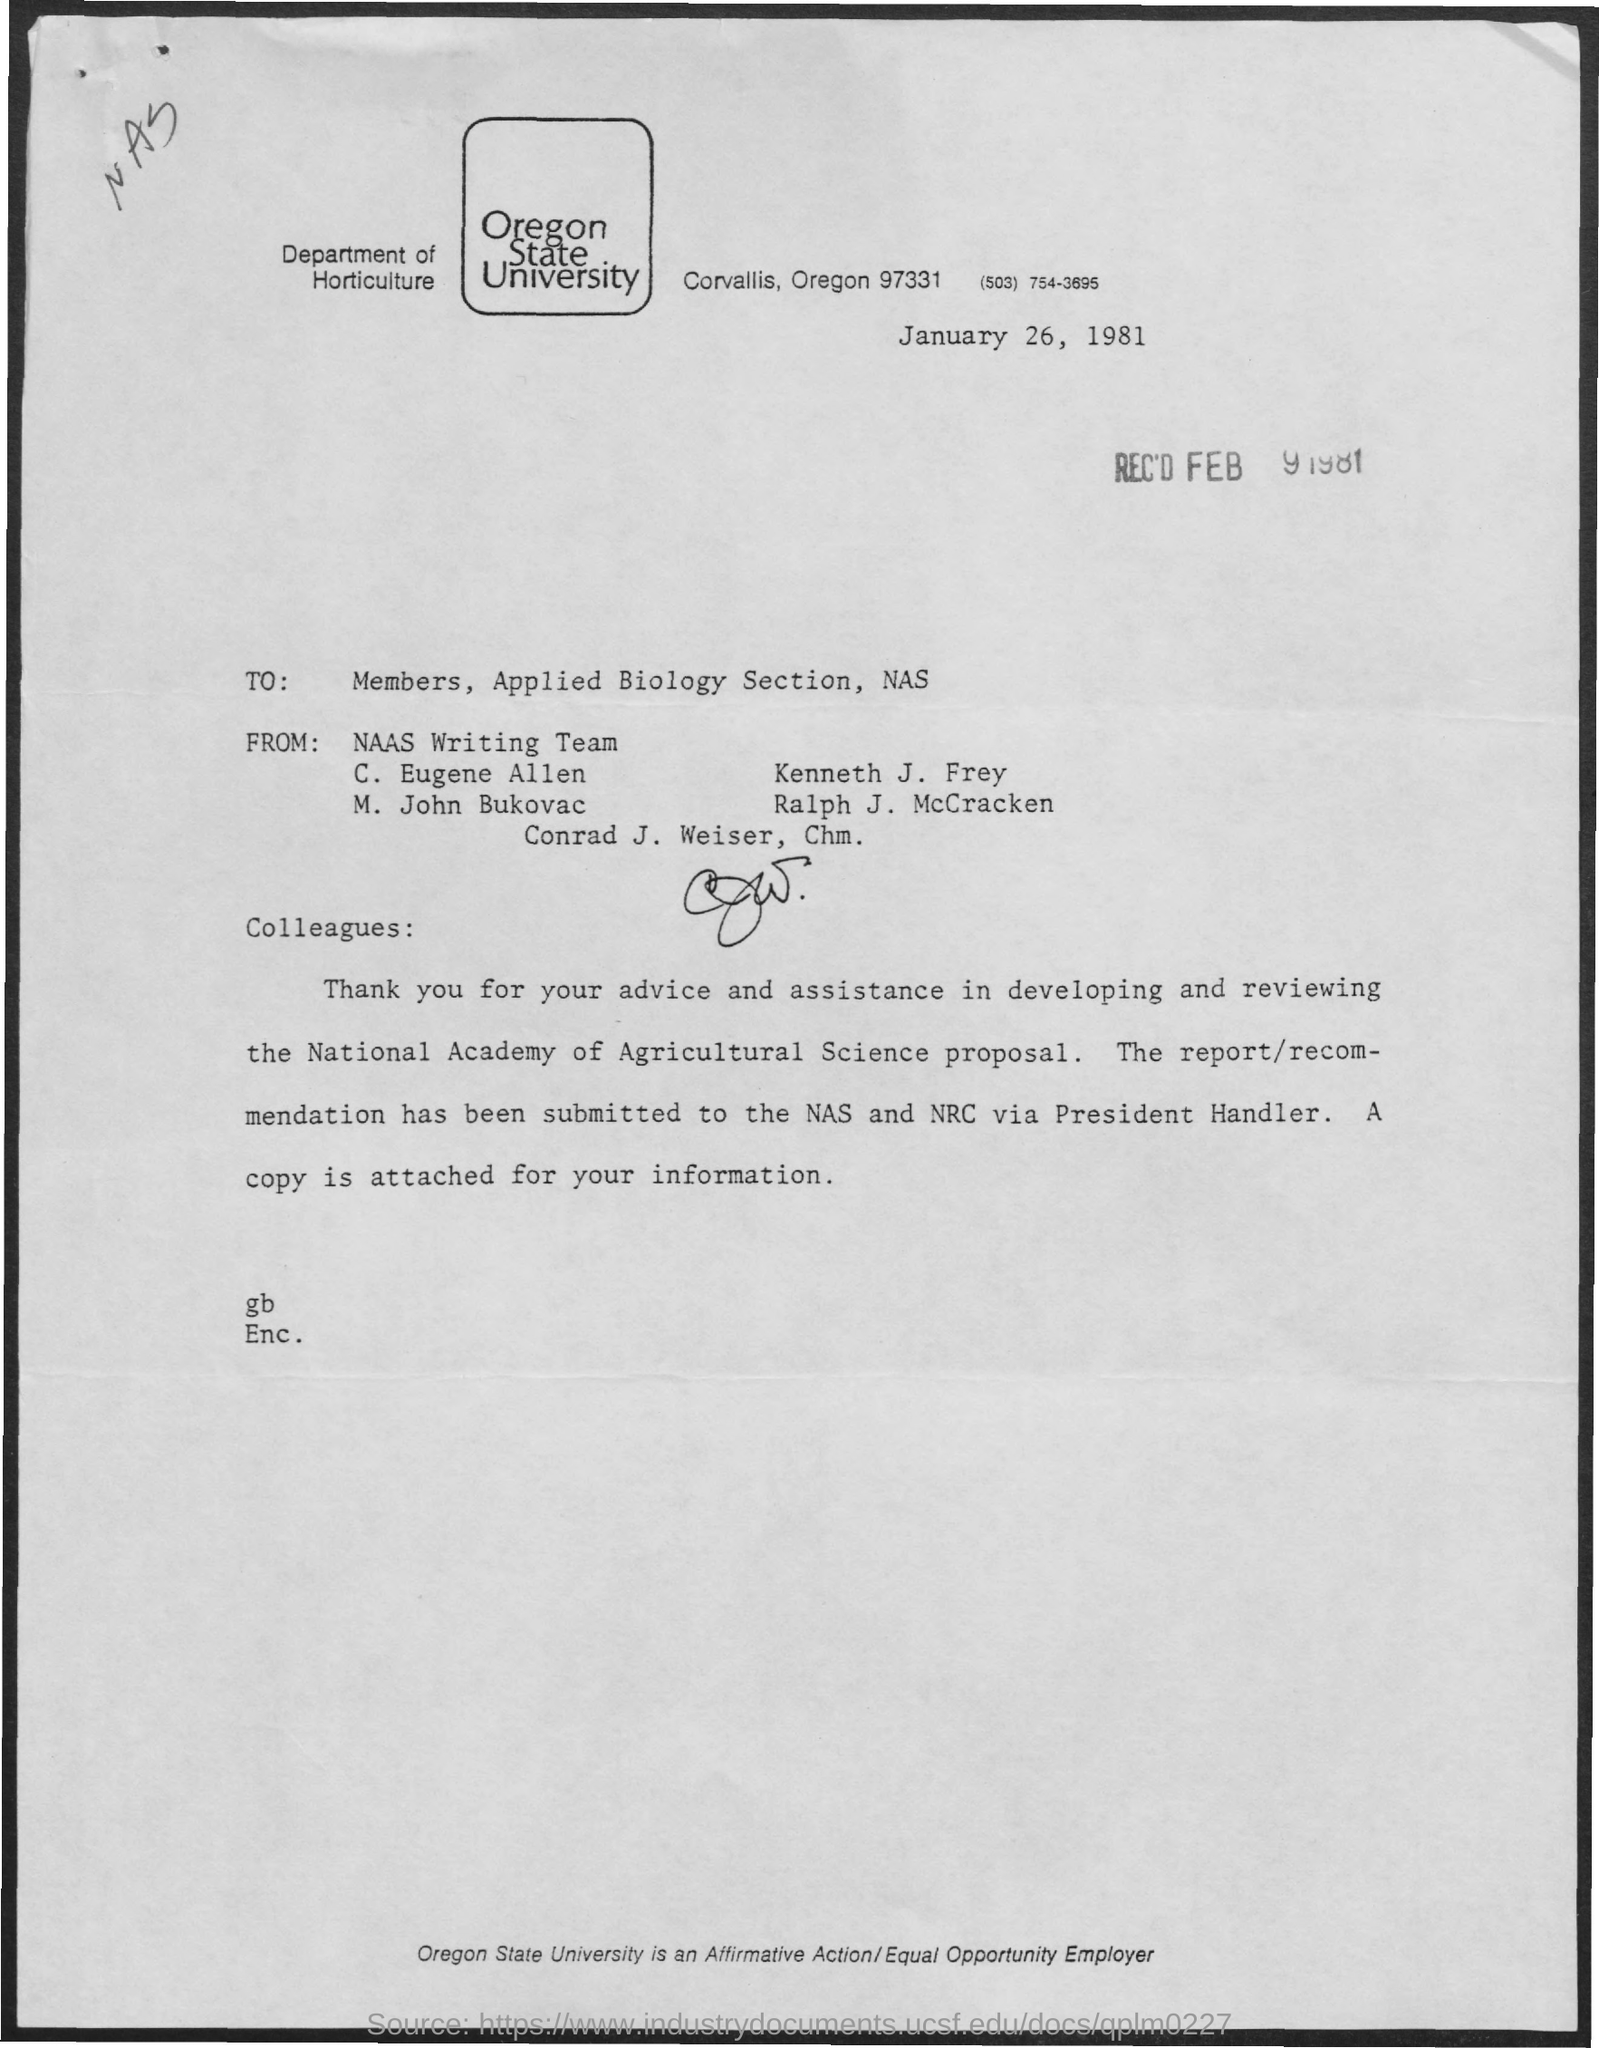Indicate a few pertinent items in this graphic. This letter was written to the members of the Applied Biology Section of the National Academy of Sciences. On January 26, 1981, the letter was written. The department mentioned in the given letter is Horticulture. The letter was received on February 9, 1981. The Oregon State University is the name of the university mentioned in the given letter. 